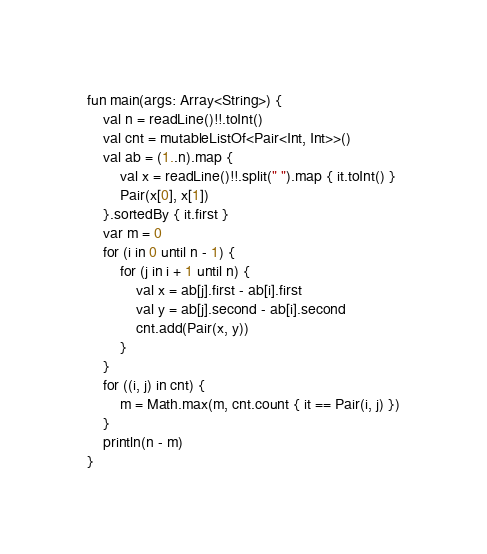Convert code to text. <code><loc_0><loc_0><loc_500><loc_500><_Kotlin_>fun main(args: Array<String>) {
    val n = readLine()!!.toInt()
    val cnt = mutableListOf<Pair<Int, Int>>()
    val ab = (1..n).map {
        val x = readLine()!!.split(" ").map { it.toInt() }
        Pair(x[0], x[1])
    }.sortedBy { it.first }
    var m = 0
    for (i in 0 until n - 1) {
        for (j in i + 1 until n) {
            val x = ab[j].first - ab[i].first
            val y = ab[j].second - ab[i].second
            cnt.add(Pair(x, y))
        }
    }
    for ((i, j) in cnt) {
        m = Math.max(m, cnt.count { it == Pair(i, j) })
    }
    println(n - m)
}</code> 